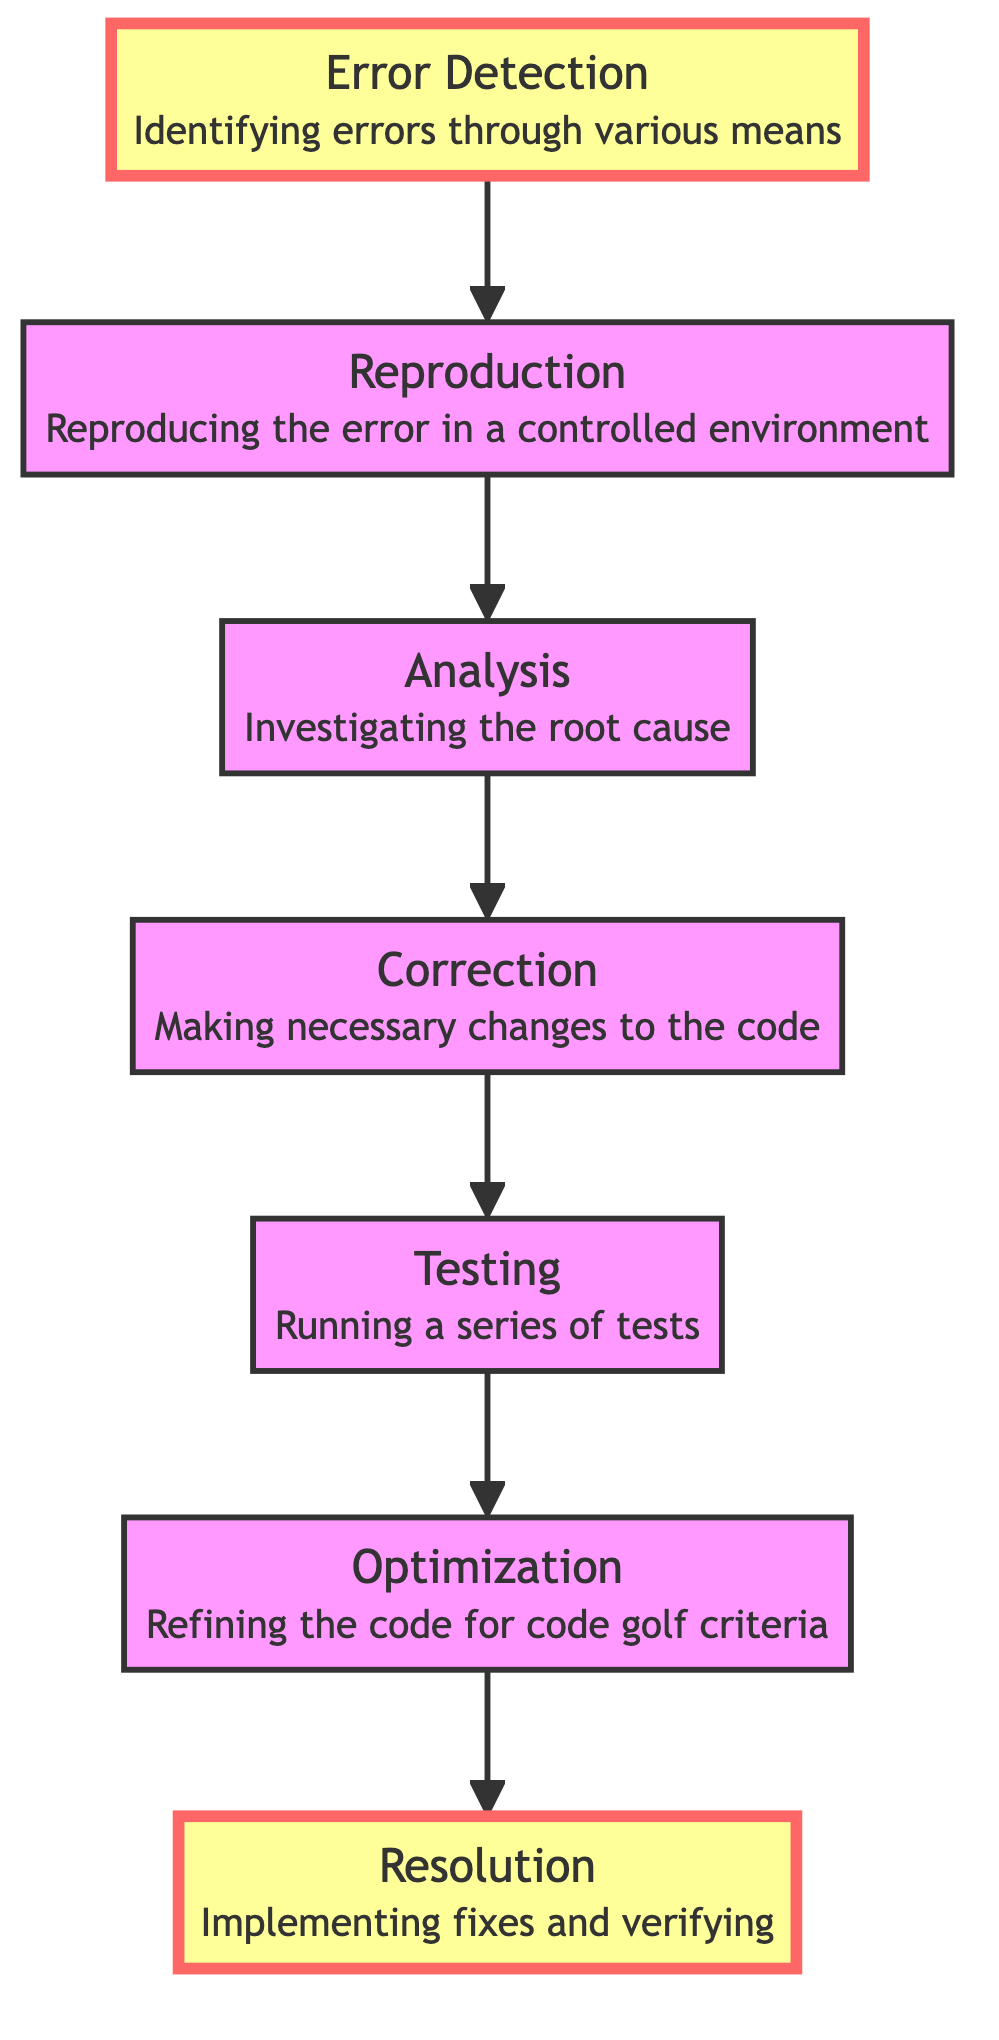What is the starting point of the diagram? The starting point of the diagram is the node labeled "Error Detection," which is the first node at the bottom of the flowchart.
Answer: Error Detection What is the final outcome of the process in this diagram? The final outcome of the process is represented by the node labeled "Resolution," which is at the top of the flowchart.
Answer: Resolution How many nodes are present in the diagram? There are a total of seven distinct nodes in the flowchart, ranging from "Error Detection" at the bottom to "Resolution" at the top.
Answer: Seven What is the relationship between "Testing" and "Correction"? The relationship is that "Testing" (node 3) directly follows "Correction" (node 4) in the process, indicating that once corrections are made, testing is performed next.
Answer: "Testing" follows "Correction" What is the purpose of the "Reproduction" step? The purpose of the "Reproduction" step is to reproduce the error in a controlled environment, allowing for detailed analysis of the error's behavior.
Answer: To reproduce the error What process follows after "Optimization"? After "Optimization," the next process is "Resolution," indicating that once the code has been optimized, it is then resolved or fixed.
Answer: Resolution What happens immediately after "Analysis"? Immediately following "Analysis," the process moves to the "Correction" step, where necessary changes are made to the code based on the analysis.
Answer: Correction How many links are there leading out of the "Error Detection" node? There is one link leading out of the "Error Detection" node to the "Reproduction" node, indicating the next step in the debugging process.
Answer: One Which node is highlighted in the diagram? The highlighted nodes are "Error Detection" at the bottom and "Resolution" at the top, emphasizing the start and end points of the process.
Answer: "Error Detection" and "Resolution" What type of flow is represented in the diagram? The flow represented in the diagram is a bottom-to-top flow, with arrows pointing upwards to show the sequence of steps in the debugging process.
Answer: Bottom-to-top flow 